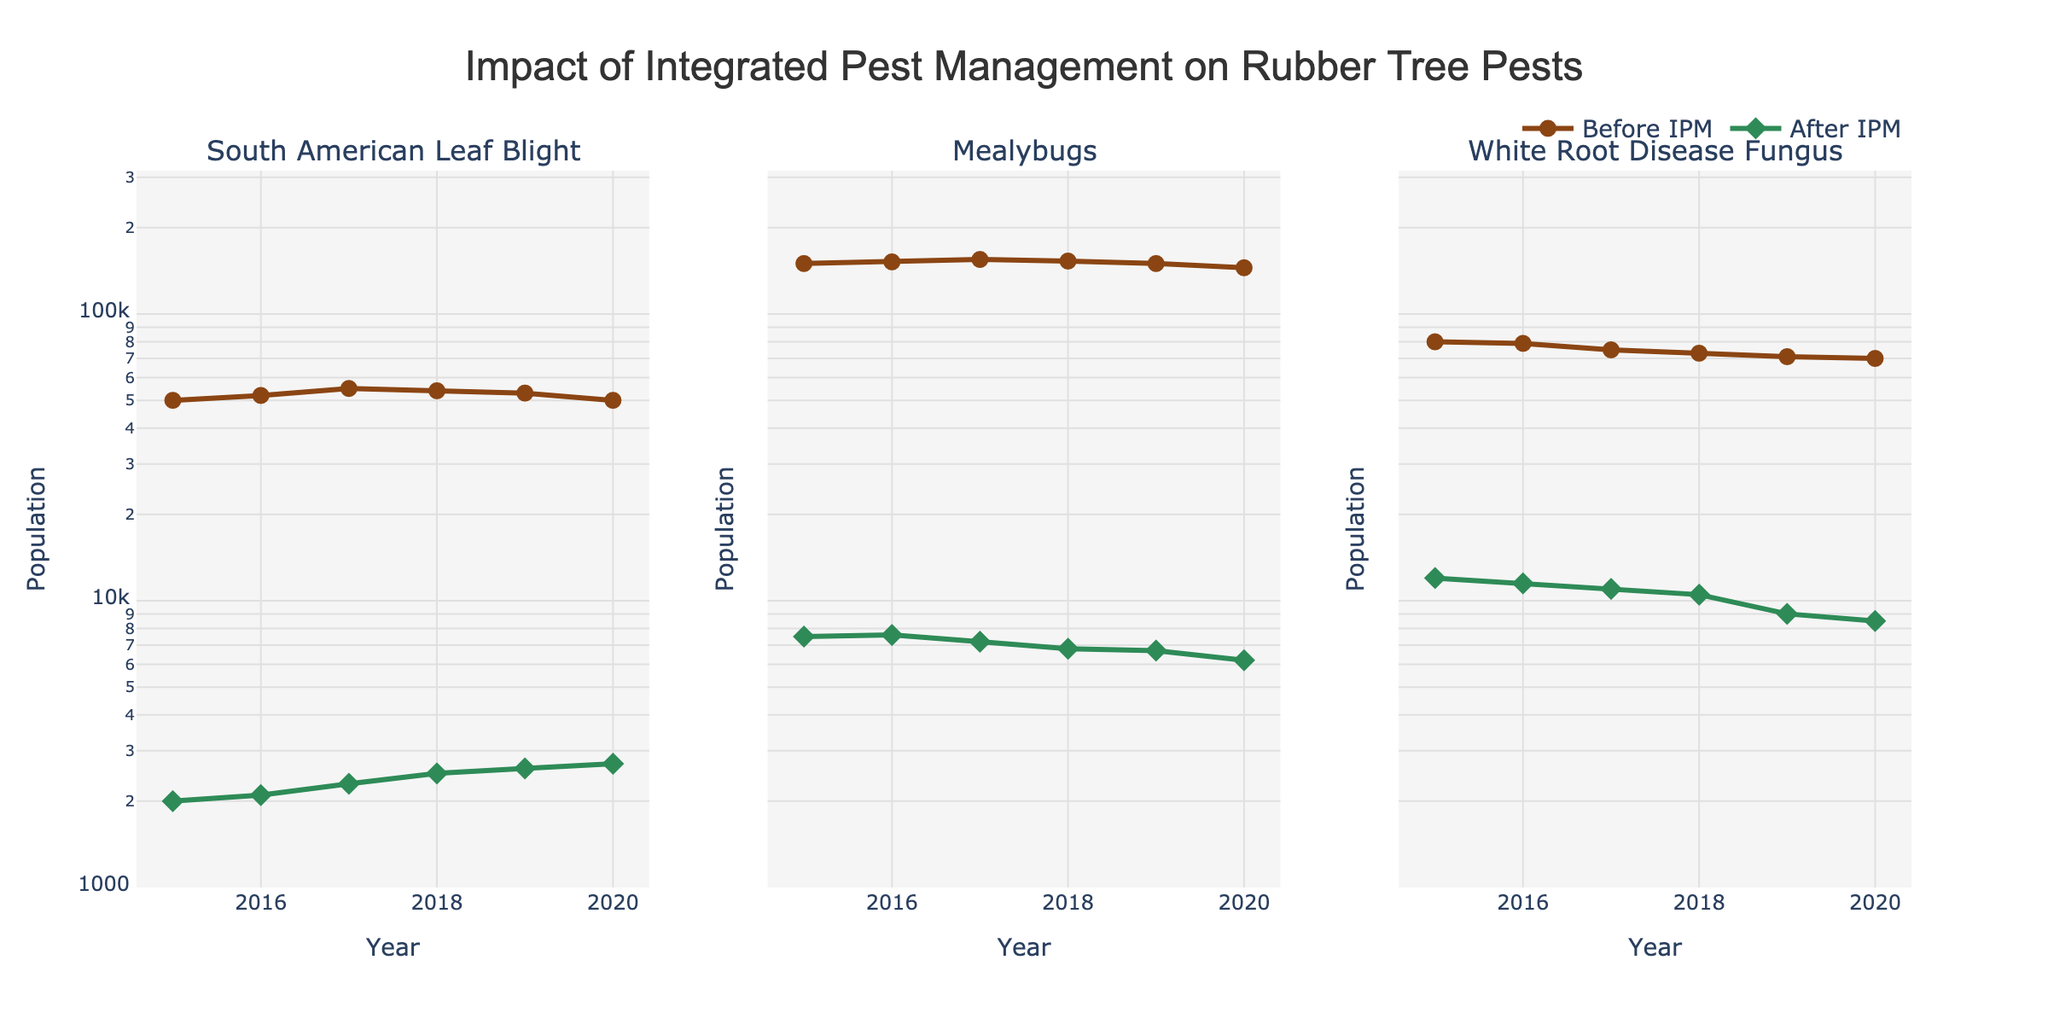What is the title of the figure? The title is usually displayed at the top of the figure. In this case, it clearly states the overall theme of the plot.
Answer: Impact of Integrated Pest Management on Rubber Tree Pests Which pest shows the most significant reduction in population after implementing IPM based on the plot? Compare the population lines for 'Before IPM' and 'After IPM' for each pest. The pest with the largest gap between these lines shows the most significant reduction.
Answer: Mealybugs Between 2016 and 2019, did the population of South American Leaf Blight increase or decrease after implementing IPM? Look at the 'After IPM' population values for South American Leaf Blight from 2016 to 2019 in the plot. Observe the trend whether it goes up or down.
Answer: Increase What is the approximate ratio of Mealybug population before and after IPM in 2018? Divide the 'Before IPM' population by the 'After IPM' population for Mealybugs in 2018 to find the ratio.
Answer: Approximately 22.5 Which year records the lowest population of White Root Disease Fungus after implementing IPM? Identify the lowest point in the 'After IPM' line for White Root Disease Fungus by checking the y-axis values for each year in the plot.
Answer: 2020 What kind of scale is used for the y-axis in the plot? The y-axis values are plotted on a logarithmic scale, which can be identified by the exponential range and different spacing of the tick marks.
Answer: Logarithmic In which year does the 'Before IPM' population of South American Leaf Blight remain constant compared to 2015? Check the 'Before IPM' line for South American Leaf Blight and see if a particular year has the same value as in 2015.
Answer: 2020 How does the population trend of Mealybugs after IPM change from 2015 to 2020? Observe the 'After IPM' population line of Mealybugs from 2015 to 2020 and note the overall direction of the trend.
Answer: Decreasing Compare the population of White Root Disease Fungus before and after IPM in 2017. Look at the specific values for 'Before IPM' and 'After IPM' populations of White Root Disease Fungus in the year 2017 in the plot and compare them.
Answer: Before: 75,000; After: 11,000 